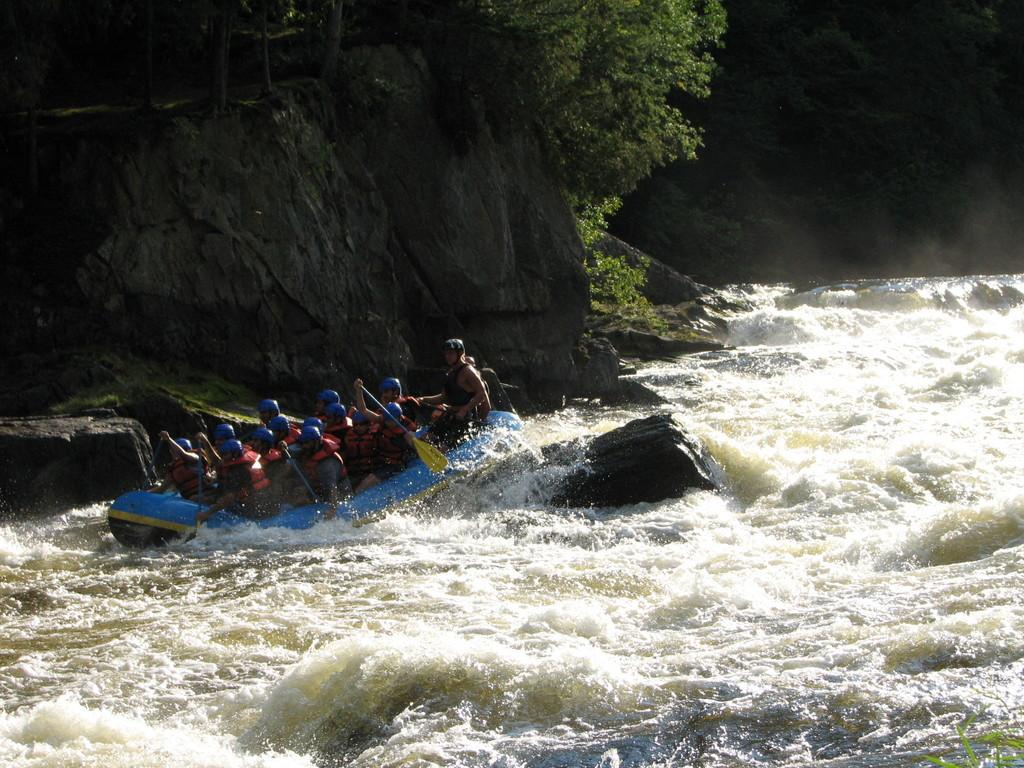What activity are the people in the image engaged in? The people in the image are rafting in the water. What is the primary element in which the people are rafting? There is water visible in the image, and the people are rafting in it. What other natural elements can be seen in the image? There are rocks and trees in the image. What type of news can be seen being broadcasted from the rocks in the image? There is no news or broadcasting equipment present in the image; it features people rafting in the water with rocks and trees in the background. 